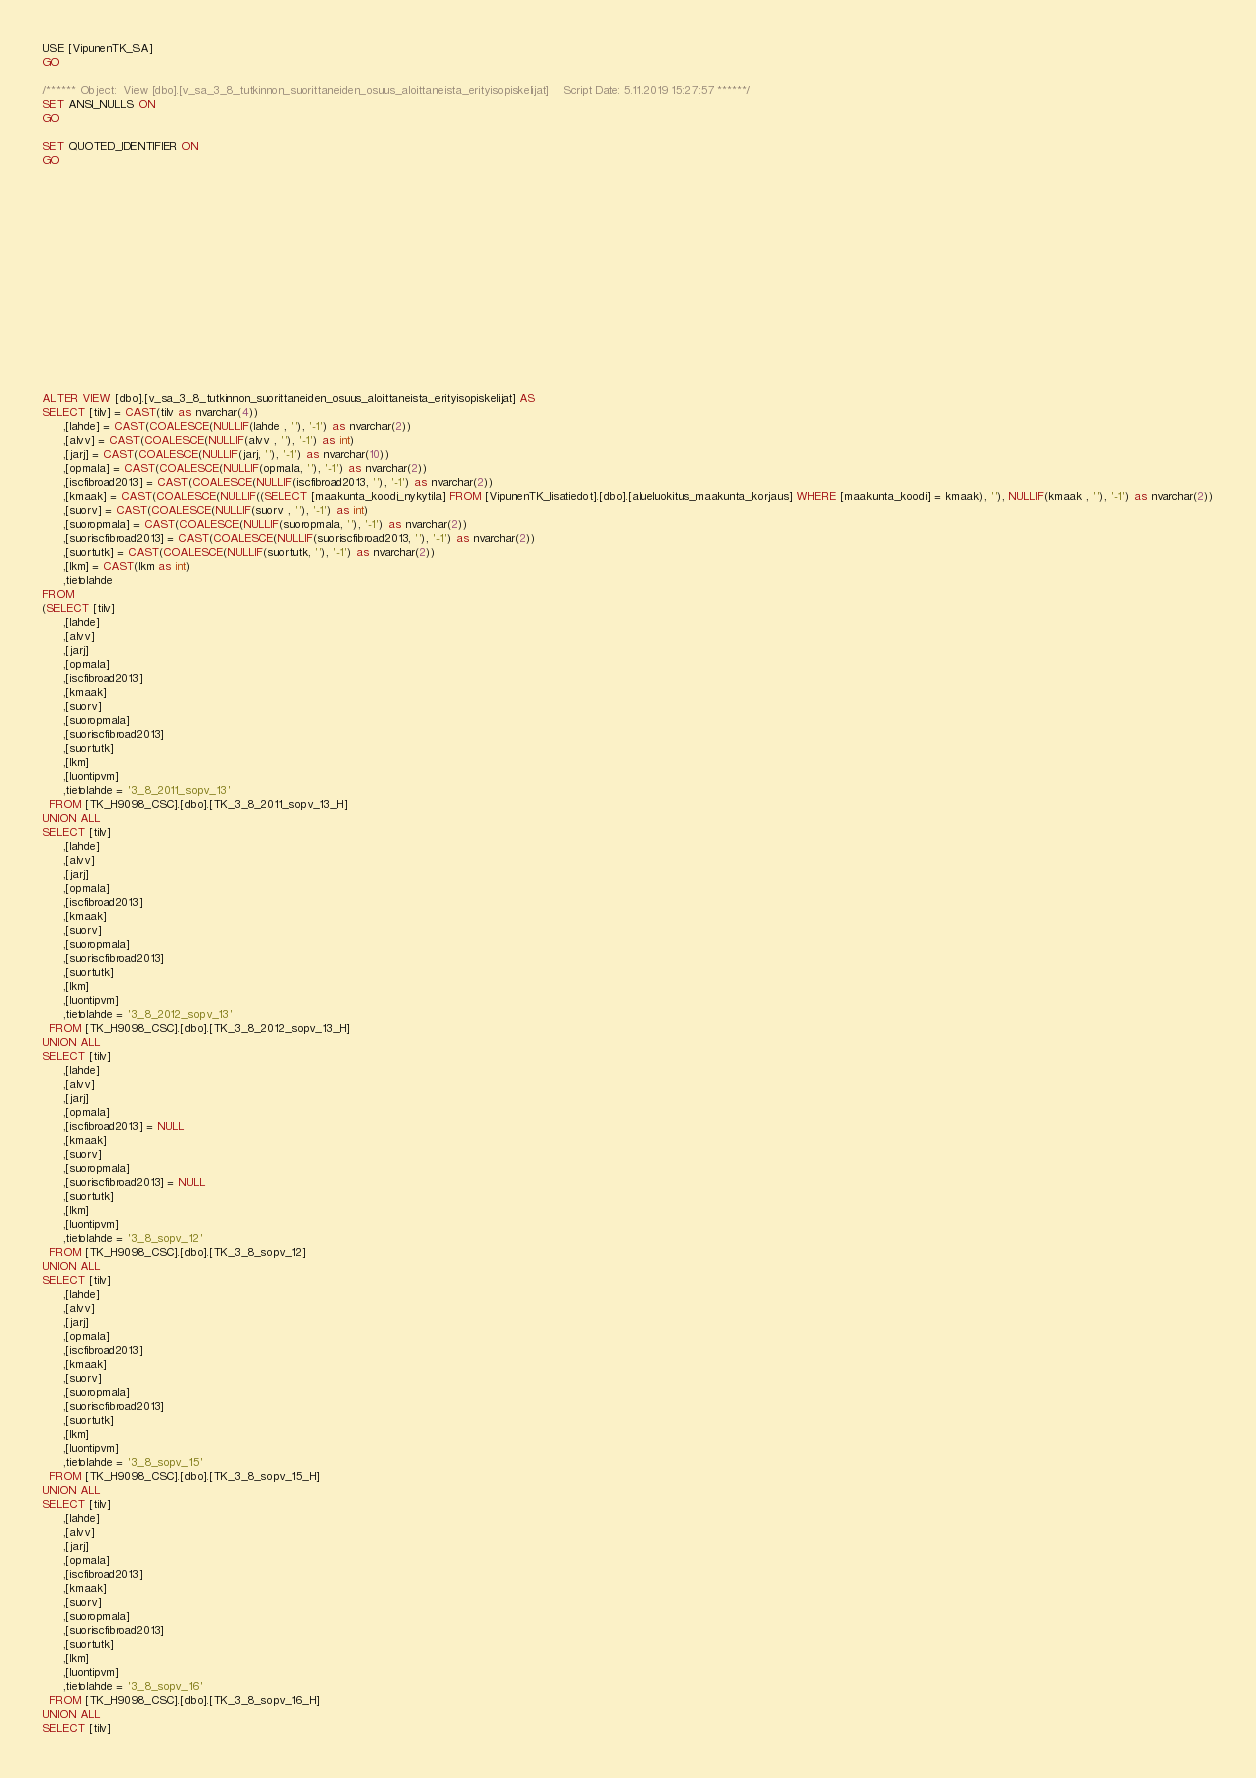<code> <loc_0><loc_0><loc_500><loc_500><_SQL_>USE [VipunenTK_SA]
GO

/****** Object:  View [dbo].[v_sa_3_8_tutkinnon_suorittaneiden_osuus_aloittaneista_erityisopiskelijat]    Script Date: 5.11.2019 15:27:57 ******/
SET ANSI_NULLS ON
GO

SET QUOTED_IDENTIFIER ON
GO
















ALTER VIEW [dbo].[v_sa_3_8_tutkinnon_suorittaneiden_osuus_aloittaneista_erityisopiskelijat] AS
SELECT [tilv] = CAST(tilv as nvarchar(4))
      ,[lahde] = CAST(COALESCE(NULLIF(lahde , ''), '-1') as nvarchar(2))
      ,[alvv] = CAST(COALESCE(NULLIF(alvv , ''), '-1') as int)
      ,[jarj] = CAST(COALESCE(NULLIF(jarj, ''), '-1') as nvarchar(10))
      ,[opmala] = CAST(COALESCE(NULLIF(opmala, ''), '-1') as nvarchar(2))
	  ,[iscfibroad2013] = CAST(COALESCE(NULLIF(iscfibroad2013, ''), '-1') as nvarchar(2))
      ,[kmaak] = CAST(COALESCE(NULLIF((SELECT [maakunta_koodi_nykytila] FROM [VipunenTK_lisatiedot].[dbo].[alueluokitus_maakunta_korjaus] WHERE [maakunta_koodi] = kmaak), ''), NULLIF(kmaak , ''), '-1') as nvarchar(2))
      ,[suorv] = CAST(COALESCE(NULLIF(suorv , ''), '-1') as int)
      ,[suoropmala] = CAST(COALESCE(NULLIF(suoropmala, ''), '-1') as nvarchar(2))
	  ,[suoriscfibroad2013] = CAST(COALESCE(NULLIF(suoriscfibroad2013, ''), '-1') as nvarchar(2))
      ,[suortutk] = CAST(COALESCE(NULLIF(suortutk, ''), '-1') as nvarchar(2))
      ,[lkm] = CAST(lkm as int)
	  ,tietolahde
FROM
(SELECT [tilv]
      ,[lahde]
      ,[alvv]
      ,[jarj]
      ,[opmala]
	  ,[iscfibroad2013]
      ,[kmaak]
      ,[suorv]
      ,[suoropmala]
	  ,[suoriscfibroad2013]
      ,[suortutk]
      ,[lkm]
      ,[luontipvm]
	  ,tietolahde = '3_8_2011_sopv_13'
  FROM [TK_H9098_CSC].[dbo].[TK_3_8_2011_sopv_13_H]
UNION ALL
SELECT [tilv]
      ,[lahde]
      ,[alvv]
      ,[jarj]
      ,[opmala]
	  ,[iscfibroad2013]
      ,[kmaak]
      ,[suorv]
      ,[suoropmala]
	  ,[suoriscfibroad2013]
      ,[suortutk]
      ,[lkm]
      ,[luontipvm]
	  ,tietolahde = '3_8_2012_sopv_13'
  FROM [TK_H9098_CSC].[dbo].[TK_3_8_2012_sopv_13_H]
UNION ALL
SELECT [tilv]
      ,[lahde]
      ,[alvv]
      ,[jarj]
      ,[opmala]
	  ,[iscfibroad2013] = NULL
      ,[kmaak]
      ,[suorv]
      ,[suoropmala]
	  ,[suoriscfibroad2013] = NULL
      ,[suortutk]
      ,[lkm]
      ,[luontipvm]
	  ,tietolahde = '3_8_sopv_12'
  FROM [TK_H9098_CSC].[dbo].[TK_3_8_sopv_12]
UNION ALL
SELECT [tilv]
      ,[lahde]
      ,[alvv]
      ,[jarj]
      ,[opmala]
	  ,[iscfibroad2013]
      ,[kmaak]
      ,[suorv]
      ,[suoropmala]
	  ,[suoriscfibroad2013]
      ,[suortutk]
      ,[lkm]
      ,[luontipvm]
	  ,tietolahde = '3_8_sopv_15'
  FROM [TK_H9098_CSC].[dbo].[TK_3_8_sopv_15_H]
UNION ALL
SELECT [tilv]
      ,[lahde]
      ,[alvv]
      ,[jarj]
      ,[opmala]
	  ,[iscfibroad2013]
      ,[kmaak]
      ,[suorv]
      ,[suoropmala]
	  ,[suoriscfibroad2013]
      ,[suortutk]
      ,[lkm]
      ,[luontipvm]
	  ,tietolahde = '3_8_sopv_16'
  FROM [TK_H9098_CSC].[dbo].[TK_3_8_sopv_16_H]
UNION ALL
SELECT [tilv]</code> 